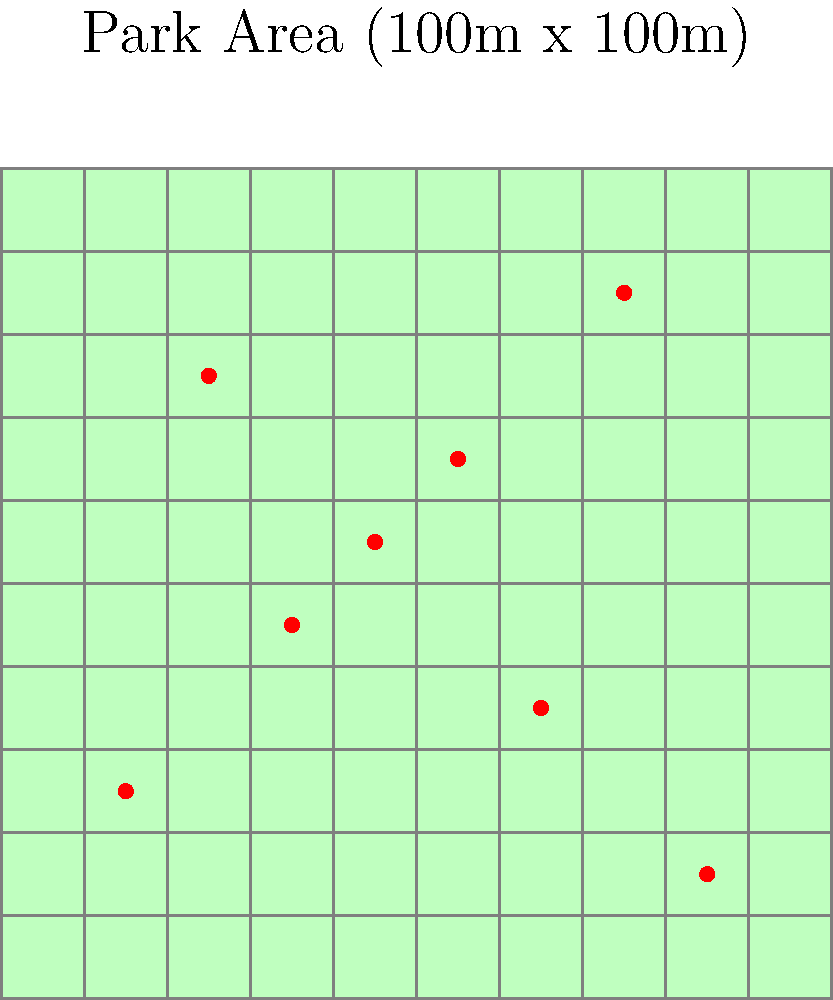As a restaurant owner planning to sponsor events in the local park, you've obtained an aerial photo of the park divided into a 10x10 grid, where each square represents a 10m x 10m area. The photo shows 8 distinct groups of people (represented by red dots). If each dot represents approximately 25 people, and you assume an even distribution of people around each dot within a 20m x 20m area, estimate the total number of people in the park. How might this information help you plan for catering and promotional activities during your sponsored events? Let's break this down step-by-step:

1) We're given that each dot represents approximately 25 people.

2) There are 8 dots visible in the park area.

3) The total number of people represented by the dots is:
   $8 \times 25 = 200$ people

4) We're told to assume an even distribution of people around each dot within a 20m x 20m area.

5) A 20m x 20m area covers 4 squares in our 10m x 10m grid.

6) The total park area is 100m x 100m = 10,000 sq meters.

7) The area covered by people (8 groups of 20m x 20m) is:
   $8 \times (20m \times 20m) = 3,200$ sq meters

8) This means the represented people cover about 32% of the park area.

9) If we assume this density is representative of the whole park, we can estimate the total number of people as:
   $200 \div 0.32 \approx 625$ people

10) For catering and promotional activities, this estimate helps in several ways:
    - Planning food and beverage quantities
    - Estimating staff needed for service and promotion
    - Determining the scale of promotional materials needed
    - Planning space requirements for activities or booths

11) It's important to note that this is an estimate and actual numbers may vary. It would be wise to plan for a range, perhaps 500-750 people, to account for variations.
Answer: Approximately 625 people 